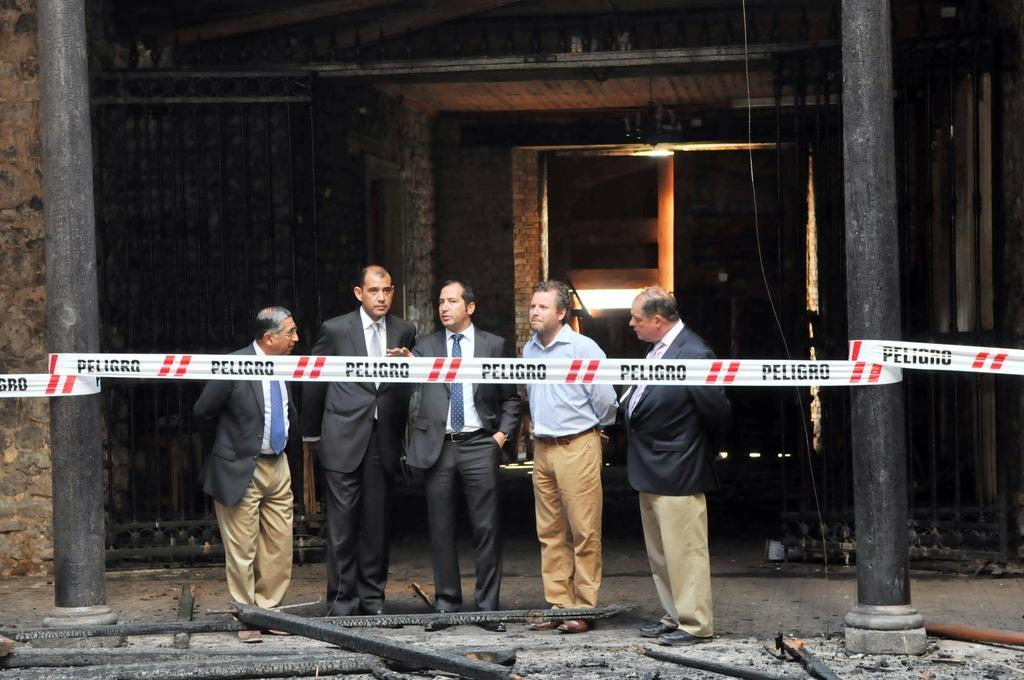How many people are in the image? There is a group of people in the image, but the exact number is not specified. What are the people doing in the image? The people are standing in the image. What is in front of the people? There is a tape in front of the people. What is behind the people? There is a wall behind the people. What can be seen at the top of the image? There is a light at the top of the image. What type of popcorn is being served during the earthquake in the image? There is no popcorn or earthquake present in the image. 